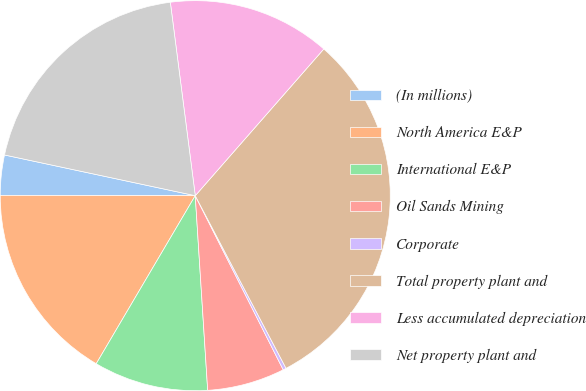<chart> <loc_0><loc_0><loc_500><loc_500><pie_chart><fcel>(In millions)<fcel>North America E&P<fcel>International E&P<fcel>Oil Sands Mining<fcel>Corporate<fcel>Total property plant and<fcel>Less accumulated depreciation<fcel>Net property plant and<nl><fcel>3.32%<fcel>16.55%<fcel>9.49%<fcel>6.43%<fcel>0.26%<fcel>30.84%<fcel>13.49%<fcel>19.61%<nl></chart> 